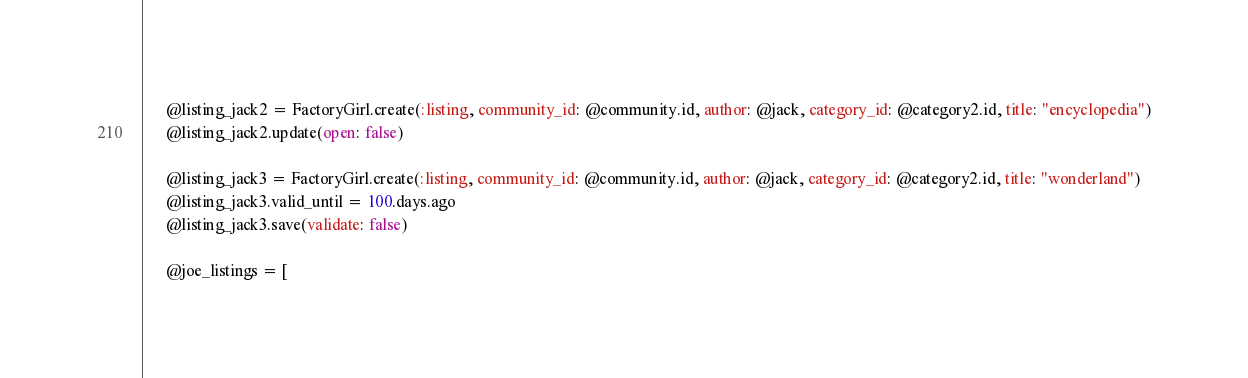<code> <loc_0><loc_0><loc_500><loc_500><_Ruby_>      @listing_jack2 = FactoryGirl.create(:listing, community_id: @community.id, author: @jack, category_id: @category2.id, title: "encyclopedia")
      @listing_jack2.update(open: false)

      @listing_jack3 = FactoryGirl.create(:listing, community_id: @community.id, author: @jack, category_id: @category2.id, title: "wonderland")
      @listing_jack3.valid_until = 100.days.ago
      @listing_jack3.save(validate: false)

      @joe_listings = [</code> 